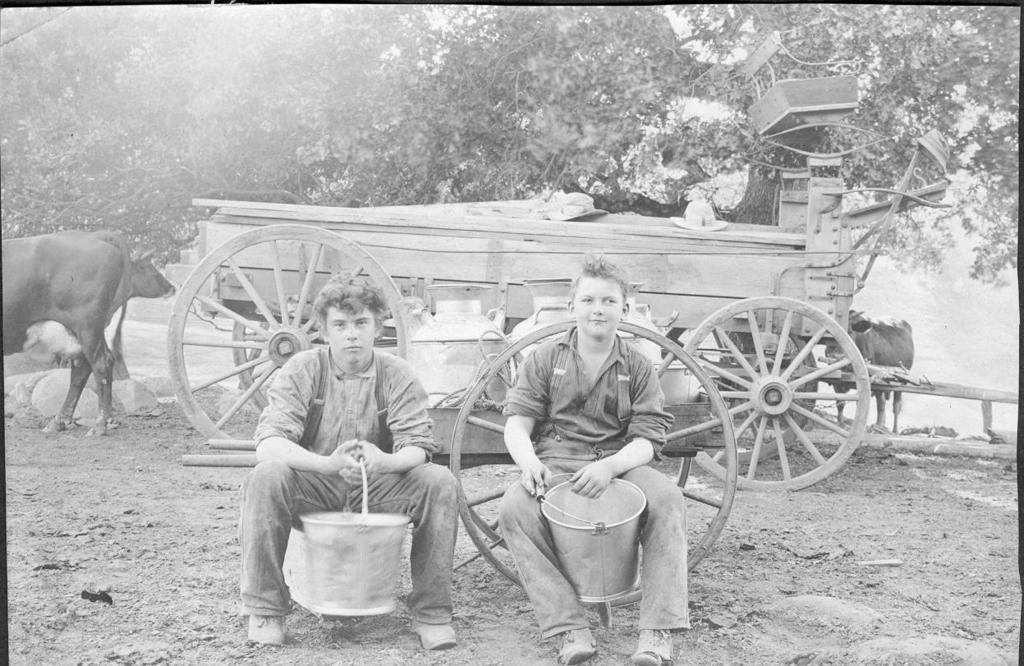Could you give a brief overview of what you see in this image? This is a black and white pic. In this image we can see two boys are sitting on the objects and holding buckets in their hands. In the background there are cows, trees, cart and sky. 